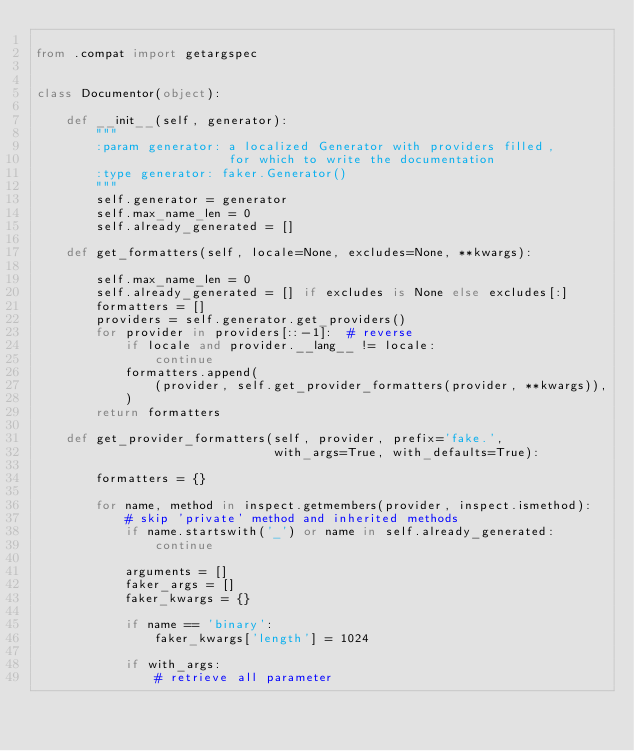Convert code to text. <code><loc_0><loc_0><loc_500><loc_500><_Python_>
from .compat import getargspec


class Documentor(object):

    def __init__(self, generator):
        """
        :param generator: a localized Generator with providers filled,
                          for which to write the documentation
        :type generator: faker.Generator()
        """
        self.generator = generator
        self.max_name_len = 0
        self.already_generated = []

    def get_formatters(self, locale=None, excludes=None, **kwargs):

        self.max_name_len = 0
        self.already_generated = [] if excludes is None else excludes[:]
        formatters = []
        providers = self.generator.get_providers()
        for provider in providers[::-1]:  # reverse
            if locale and provider.__lang__ != locale:
                continue
            formatters.append(
                (provider, self.get_provider_formatters(provider, **kwargs)),
            )
        return formatters

    def get_provider_formatters(self, provider, prefix='fake.',
                                with_args=True, with_defaults=True):

        formatters = {}

        for name, method in inspect.getmembers(provider, inspect.ismethod):
            # skip 'private' method and inherited methods
            if name.startswith('_') or name in self.already_generated:
                continue

            arguments = []
            faker_args = []
            faker_kwargs = {}

            if name == 'binary':
                faker_kwargs['length'] = 1024

            if with_args:
                # retrieve all parameter</code> 